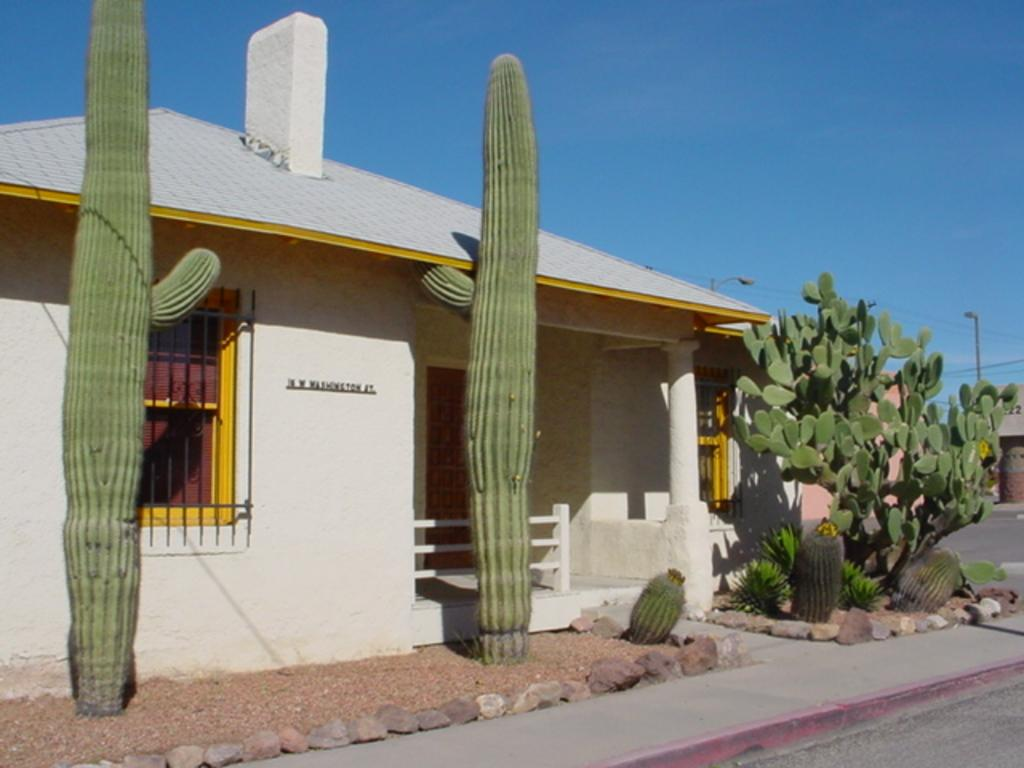What type of structure is visible in the image? There is a house in the image. What features can be seen on the house? The house has windows. What is located in front of the house? There are plants and stones in front of the house. What can be seen in the background of the image? There is a pole and a blue sky in the background of the image. What type of furniture can be seen inside the house in the image? There is no furniture visible inside the house in the image; only the exterior of the house is shown. 